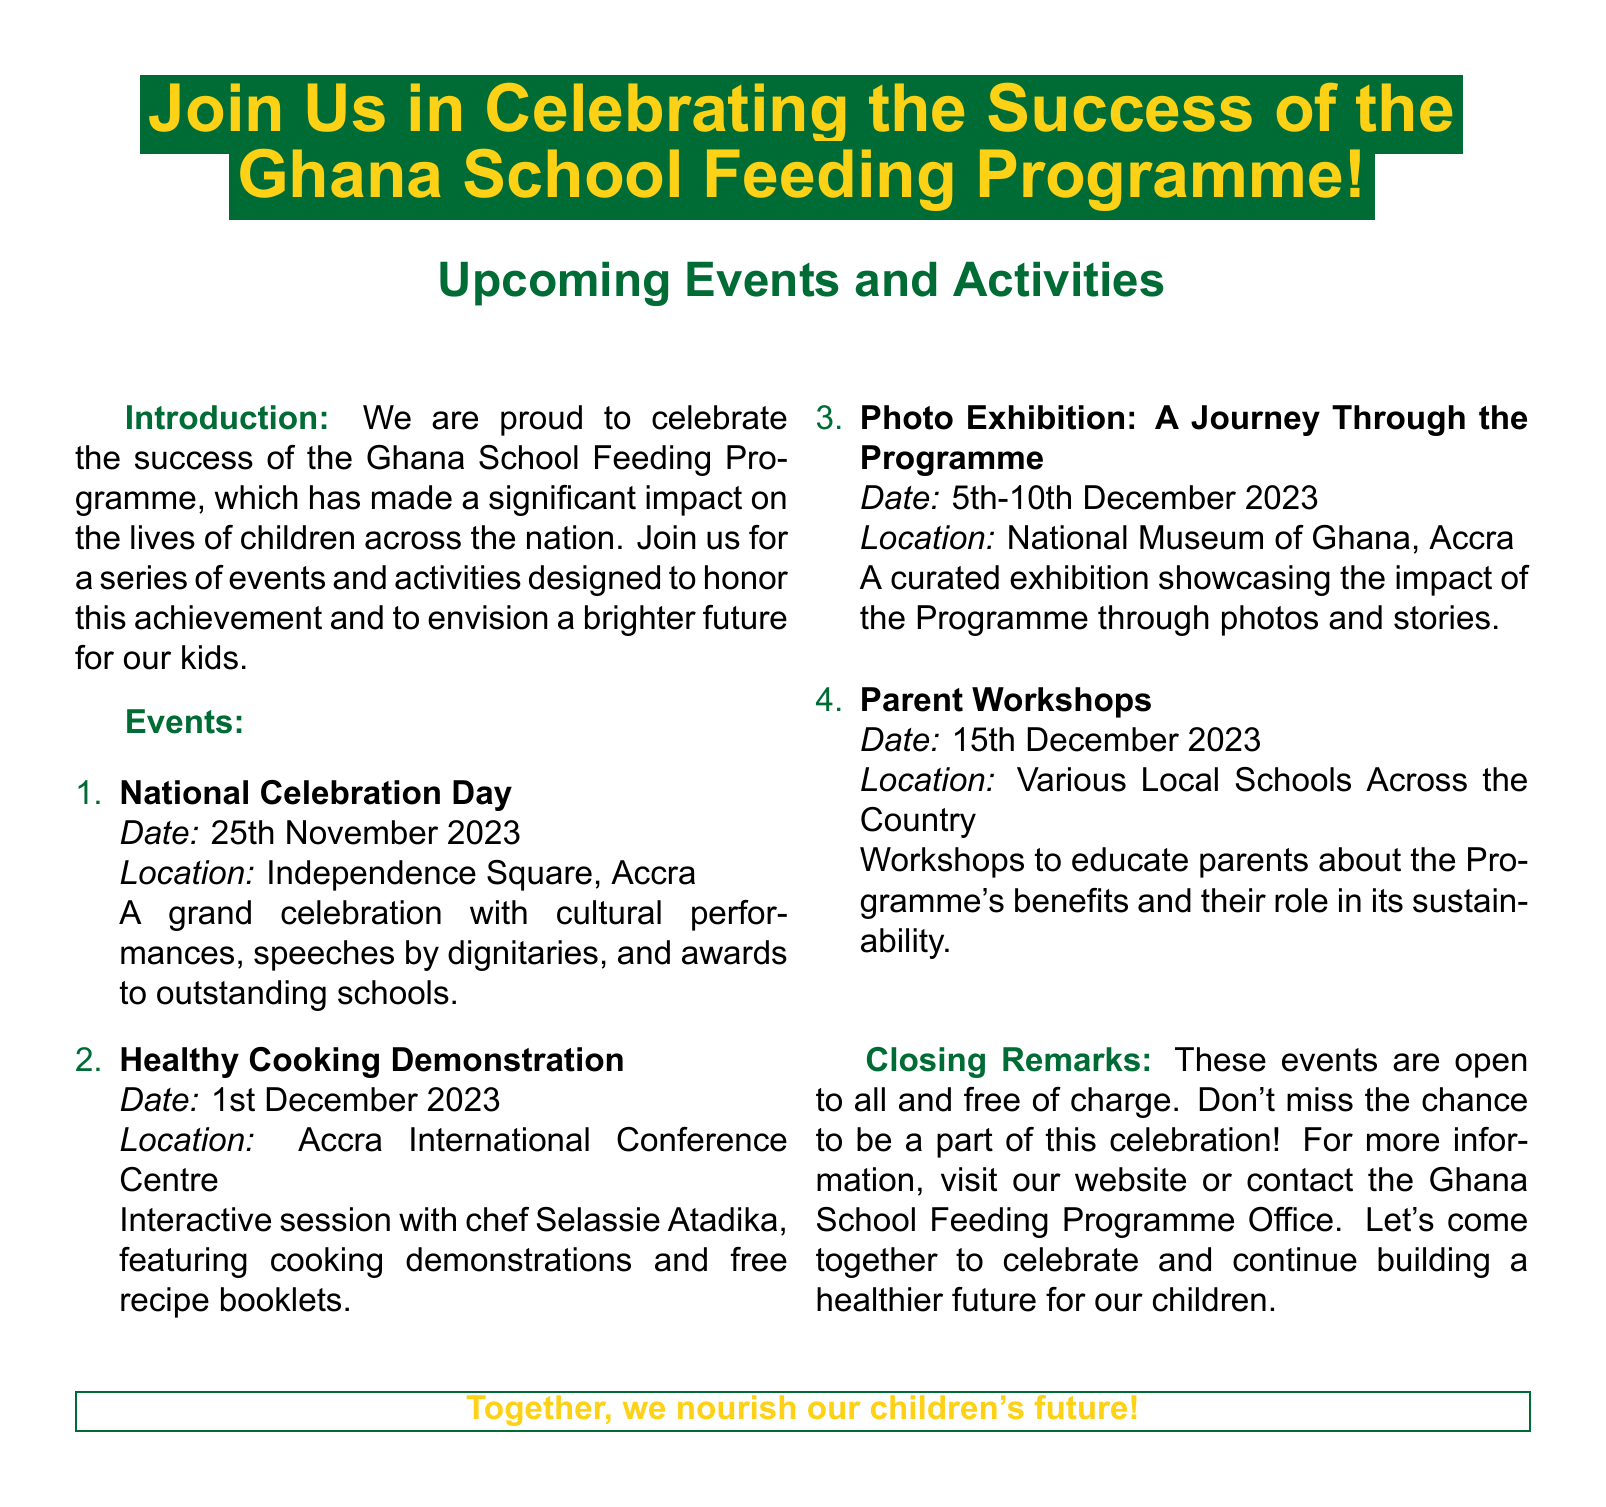What is the date of the National Celebration Day? The National Celebration Day is scheduled for 25th November 2023.
Answer: 25th November 2023 Where will the Healthy Cooking Demonstration take place? The Healthy Cooking Demonstration will be held at Accra International Conference Centre.
Answer: Accra International Conference Centre What is one of the activities planned on 1st December 2023? On 1st December 2023, there will be cooking demonstrations with chef Selassie Atadika.
Answer: Cooking demonstrations with chef Selassie Atadika What is the intent behind the Parent Workshops on 15th December 2023? The workshops aim to educate parents about the Programme's benefits and sustainability.
Answer: Educate parents about benefits and sustainability Which location will host a photo exhibition? The photo exhibition will take place at the National Museum of Ghana, Accra.
Answer: National Museum of Ghana, Accra What type of event is scheduled for 5th-10th December 2023? That period will feature a photo exhibition showcasing the Programme's impact.
Answer: Photo exhibition Are the events mentioned in the document free of charge? The document states that these events are open to all and free of charge.
Answer: Free of charge What is the main theme of the flyer? The theme of the flyer is to celebrate the success of the Ghana School Feeding Programme.
Answer: Celebrate the success of the Ghana School Feeding Programme 